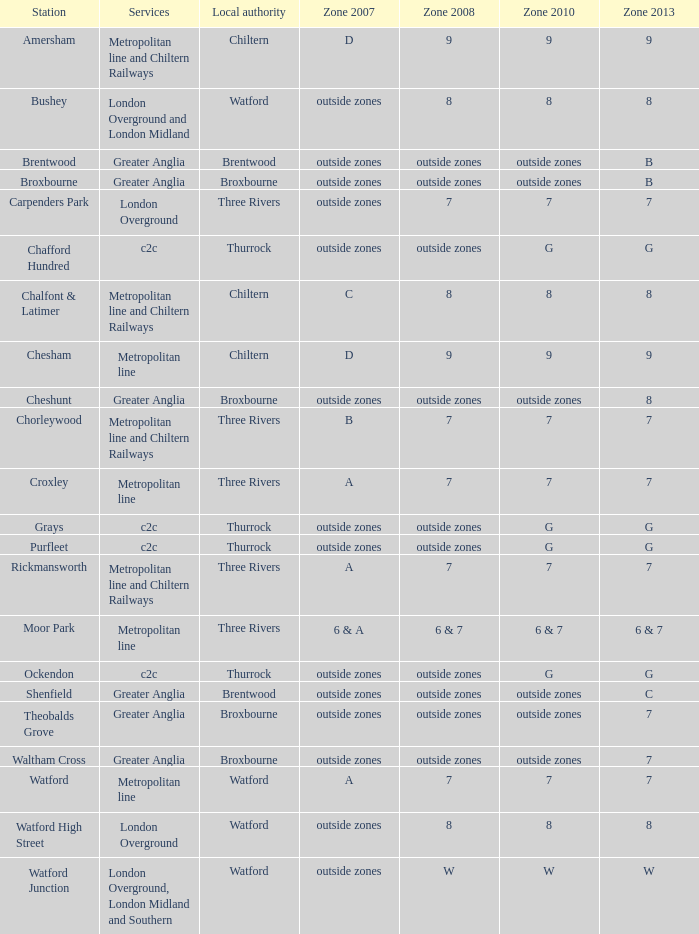Which Local authority has Services of greater anglia? Brentwood, Broxbourne, Broxbourne, Brentwood, Broxbourne, Broxbourne. 